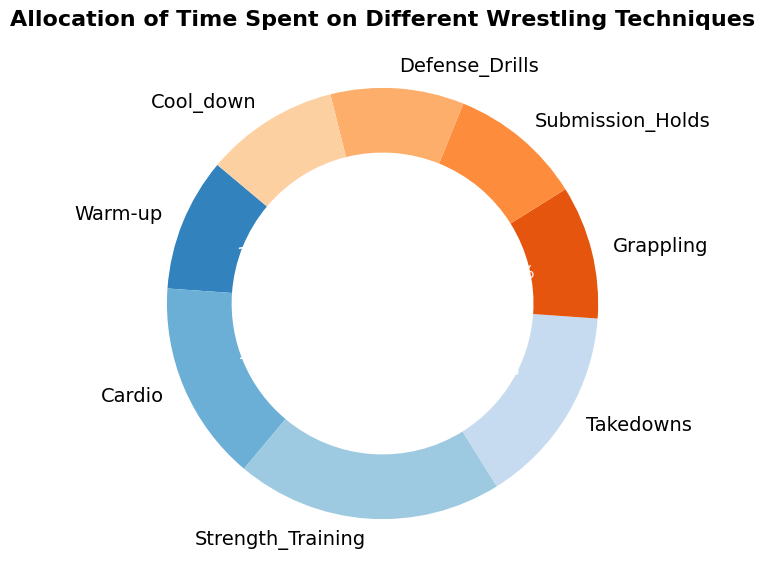What's the total percentage of time spent on both Warm-up and Cool-down? To find the total percentage of time spent on both Warm-up and Cool-down, simply add their respective percentages: 10% + 10% = 20%.
Answer: 20% Which technique has the least amount of time allocated to it? By inspecting the pie chart, all techniques except Strength Training (20%) and Cardio and Takedowns (both 15%) have a 10% allocation. Since there are multiple techniques with the lowest time allocation, any of these are the answer. Choose one, e.g., Warm-up.
Answer: Warm-up How much more time is spent on Cardio compared to Grappling? The time spent on Cardio is 15%, and the time spent on Grappling is 10%. The difference is calculated as 15% - 10% = 5%.
Answer: 5% Are there any techniques that have equal time allocations? If so, which ones? By inspecting the pie chart, multiple techniques share the same percentage allocation. Specifically, Warm-up, Grappling, Submission Holds, Defense Drills, and Cool-down each have an allocation of 10%.
Answer: Warm-up, Grappling, Submission Holds, Defense Drills, Cool-down Compare the time spent on Submission Holds to the time spent on Takedowns. Is it less or more? Submission Holds have a 10% allocation, while Takedowns have a 15% allocation. Therefore, less time is spent on Submission Holds compared to Takedowns.
Answer: Less What is the total percentage of time spent on all techniques except Strength Training and Cardio? First, sum the percentages of all other techniques: Warm-up (10%), Takedowns (15%), Grappling (10%), Submission Holds (10%), Defense Drills (10%), Cool-down (10%) which equals 65%.
Answer: 65% If you doubled the time spent on Defense Drills, what would the new percentage be? The original time spent on Defense Drills is 10%. If we double this, we get 2 * 10% = 20%.
Answer: 20% Which technique has the highest time allocation? By inspecting the pie chart, Strength Training has the highest time allocation at 20%.
Answer: Strength Training What is the average time allocation for all the techniques represented in the pie chart? To find the average, sum all the percentages and then divide by the number of techniques: (10 + 15 + 20 + 15 + 10 + 10 + 10 + 10) / 8 = 100 / 8 = 12.5%.
Answer: 12.5% 